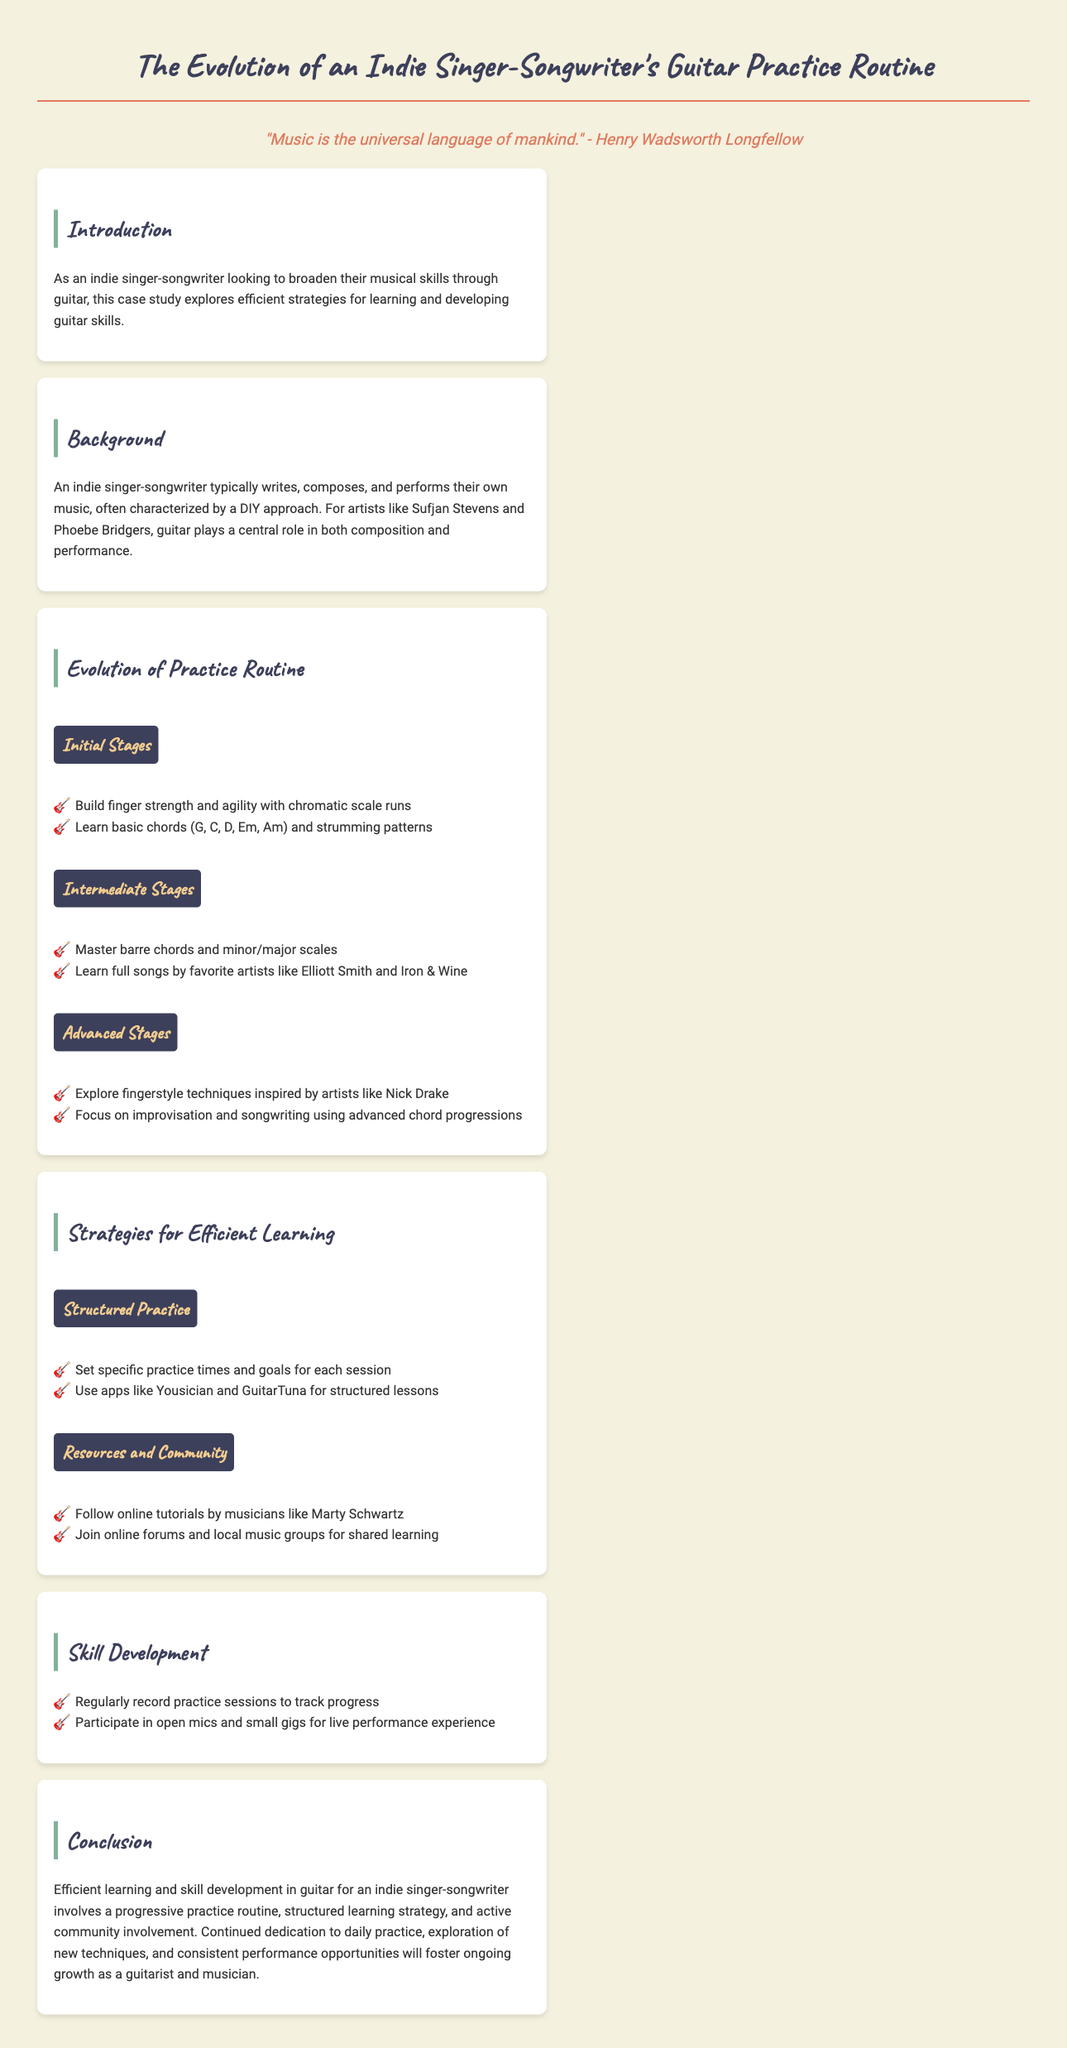what is the title of the document? The title is presented at the top of the document as a heading.
Answer: The Evolution of an Indie Singer-Songwriter's Guitar Practice Routine who is quoted in the document? The quote in the document is attributed to a well-known author whose full name is mentioned.
Answer: Henry Wadsworth Longfellow what primary skill is focused on in the practice routine? The document specifically states that the focus is on a particular musical instrument used by the indie singer-songwriter.
Answer: Guitar which artist is mentioned as an inspiration for fingerstyle techniques? The document mentions a specific artist known for his fingerstyle guitar playing which influences the practice routine.
Answer: Nick Drake how many stages are outlined in the practice routine evolution? The document lists a sequence of stages in the evolution of the practice routine.
Answer: Three what is one of the structured practice strategies mentioned? The document provides specific strategies that help organize practice sessions effectively.
Answer: Set specific practice times which app is suggested for structured lessons? The document lists specific applications that can aid in guitar learning, naming one that is particularly highlighted.
Answer: Yousician what type of events does the document recommend for gaining performance experience? The document suggests a particular kind of venue for practicing live performance skills.
Answer: Open mics what is a key aspect of skill development mentioned? The document outlines specific methods for tracking progress during the learning process.
Answer: Regularly record practice sessions 